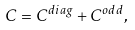<formula> <loc_0><loc_0><loc_500><loc_500>C = C ^ { d i a g } + C ^ { o d d } ,</formula> 